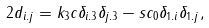<formula> <loc_0><loc_0><loc_500><loc_500>2 d _ { i . j } = k _ { 3 } c \delta _ { i . 3 } \delta _ { j . 3 } - s c _ { 0 } \delta _ { 1 . i } \delta _ { 1 . j } ,</formula> 